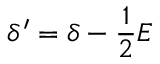Convert formula to latex. <formula><loc_0><loc_0><loc_500><loc_500>\delta ^ { \prime } = \delta - \frac { 1 } { 2 } E</formula> 